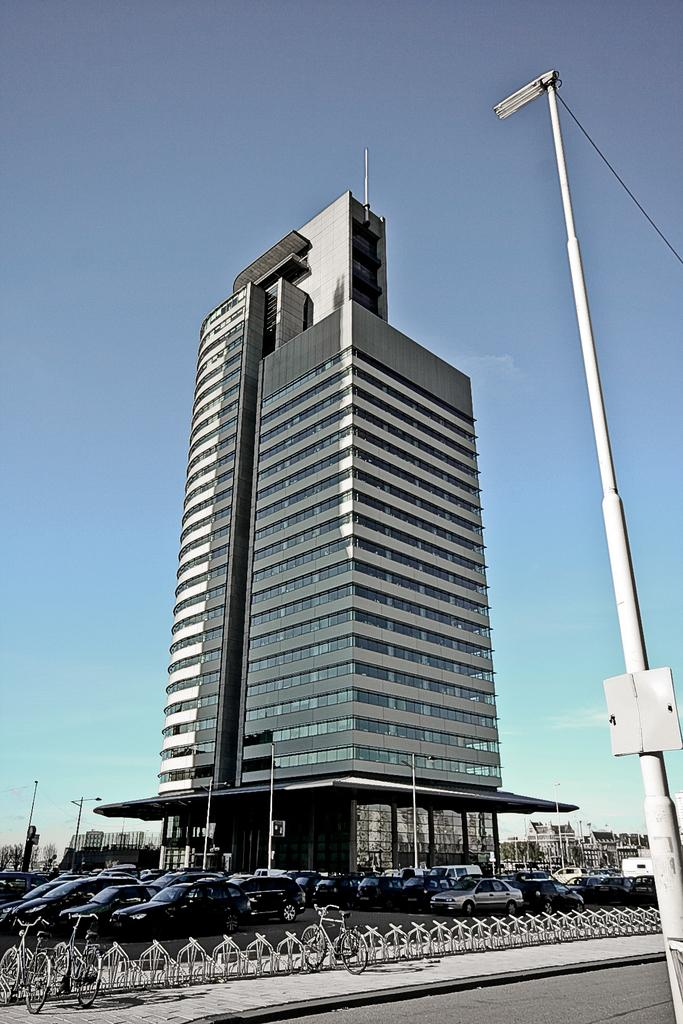What types of objects are present in the image? There are vehicles, a building, poles, lights, and trees in the image. Can you describe the structure in the image? There is a building in the image. What are the poles used for in the image? The poles are likely used to support the lights in the image. What can be seen in the background of the image? The sky is visible in the background of the image. How does the mass of the trees affect the movement of the vehicles in the image? The mass of the trees does not affect the movement of the vehicles in the image, as they are separate entities and not interacting with each other. 